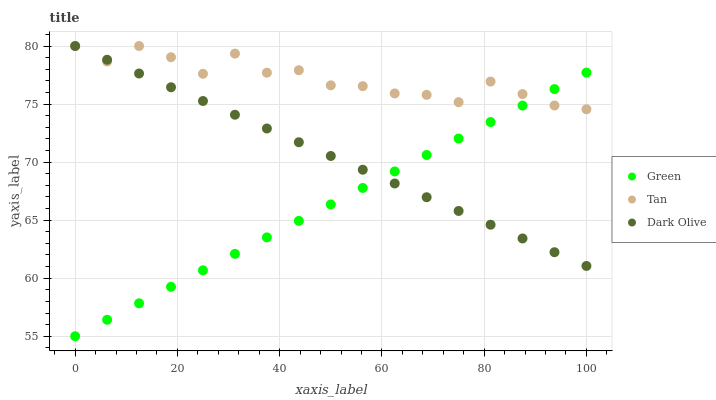Does Green have the minimum area under the curve?
Answer yes or no. Yes. Does Tan have the maximum area under the curve?
Answer yes or no. Yes. Does Dark Olive have the minimum area under the curve?
Answer yes or no. No. Does Dark Olive have the maximum area under the curve?
Answer yes or no. No. Is Green the smoothest?
Answer yes or no. Yes. Is Tan the roughest?
Answer yes or no. Yes. Is Dark Olive the smoothest?
Answer yes or no. No. Is Dark Olive the roughest?
Answer yes or no. No. Does Green have the lowest value?
Answer yes or no. Yes. Does Dark Olive have the lowest value?
Answer yes or no. No. Does Dark Olive have the highest value?
Answer yes or no. Yes. Does Green have the highest value?
Answer yes or no. No. Does Tan intersect Green?
Answer yes or no. Yes. Is Tan less than Green?
Answer yes or no. No. Is Tan greater than Green?
Answer yes or no. No. 